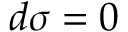<formula> <loc_0><loc_0><loc_500><loc_500>d { \sigma } = 0</formula> 